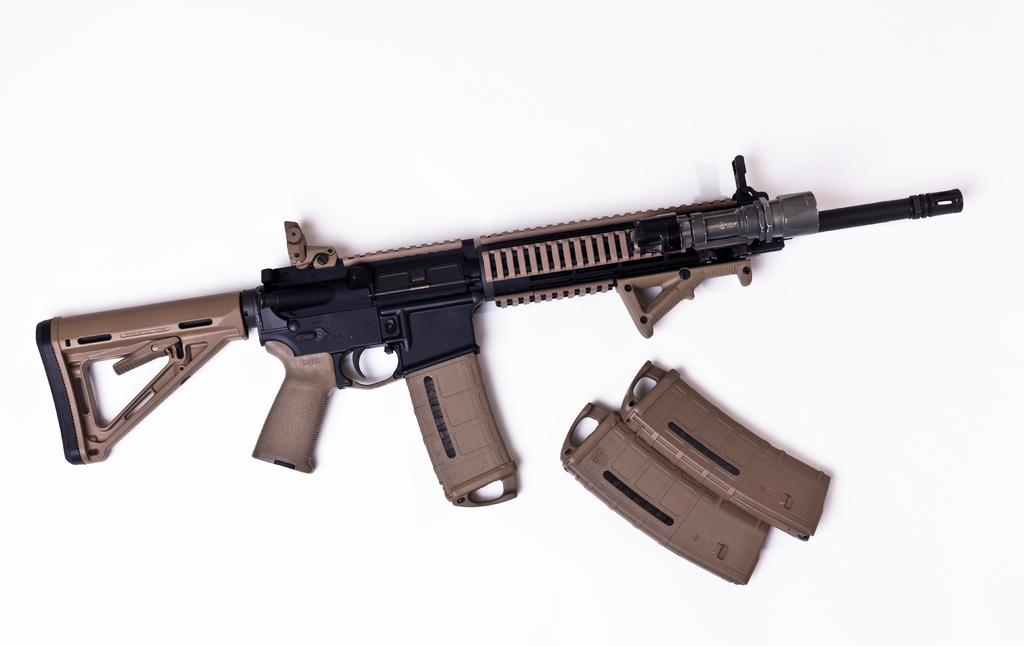What is the main object in the picture? There is a gun in the picture. Are there any accessories or related items visible in the image? Yes, there are two magazines beside the gun. What type of oven is visible in the image? There is no oven present in the image. 